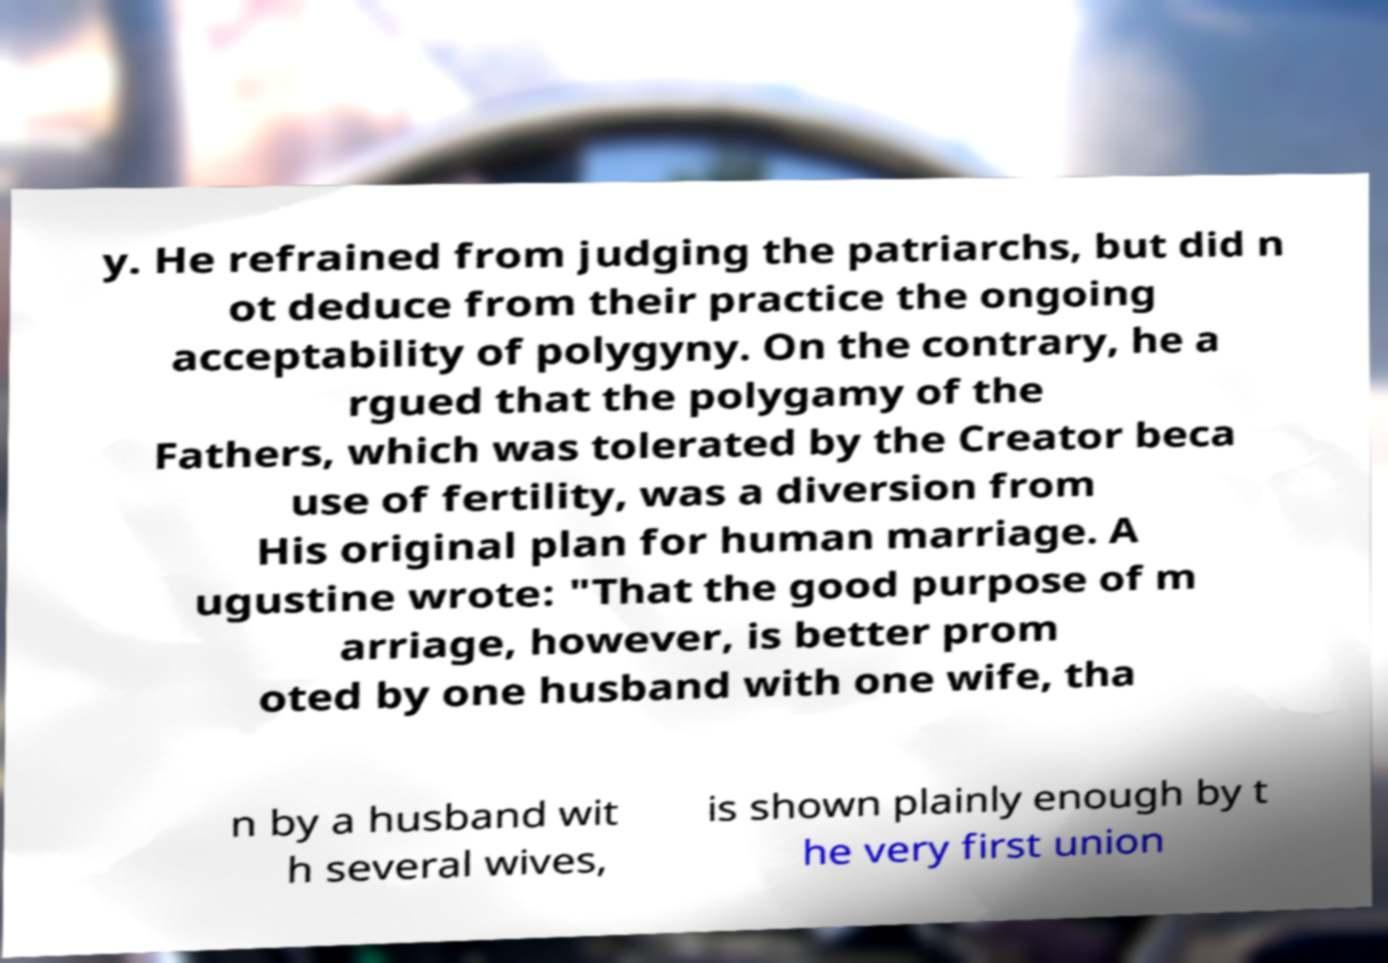Can you read and provide the text displayed in the image?This photo seems to have some interesting text. Can you extract and type it out for me? y. He refrained from judging the patriarchs, but did n ot deduce from their practice the ongoing acceptability of polygyny. On the contrary, he a rgued that the polygamy of the Fathers, which was tolerated by the Creator beca use of fertility, was a diversion from His original plan for human marriage. A ugustine wrote: "That the good purpose of m arriage, however, is better prom oted by one husband with one wife, tha n by a husband wit h several wives, is shown plainly enough by t he very first union 